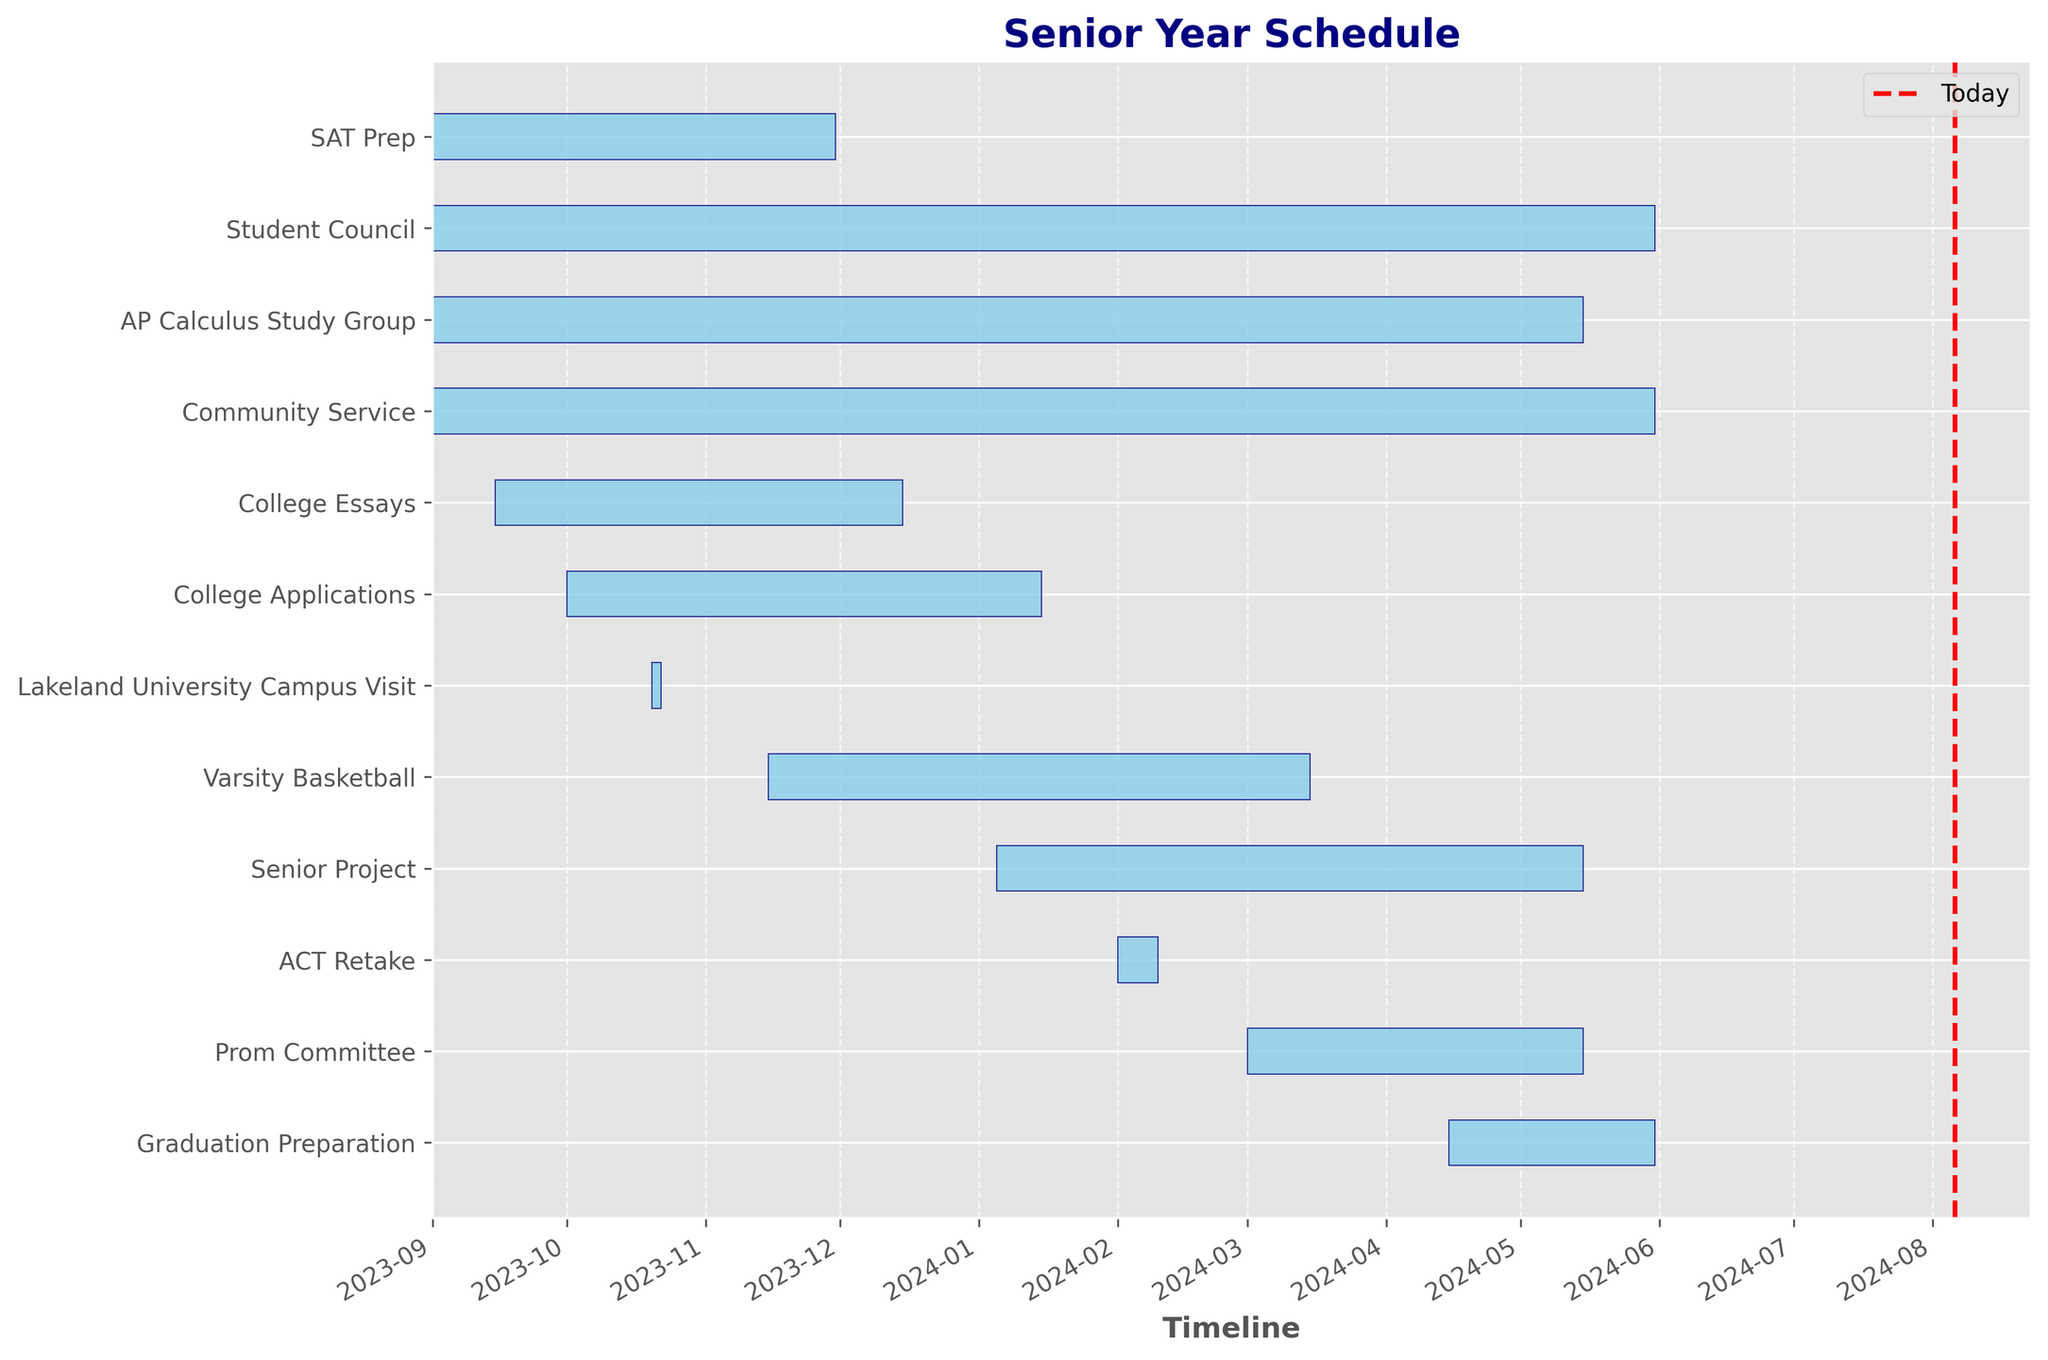What is the title of the chart? The title is located at the top center of the chart and usually provides a summary of what the chart is about. On this chart, the title is bold and colored in navy.
Answer: Senior Year Schedule How many tasks overlap with the SAT Prep period? Look at the bar for the SAT Prep task and observe which bars have start and end dates that fall within its range (2023-09-01 to 2023-11-30).
Answer: 5 (Student Council, AP Calculus Study Group, Community Service, College Applications, College Essays) Which task has the longest duration? Look at the length of each bar. The longest bar visually represents the longest duration. In this case, the Student Council bar is the longest.
Answer: Student Council What is the start date and end date for the Graduation Preparation task? Find the bar labeled "Graduation Preparation" and note the start and end dates at the ends of the bar.
Answer: 2024-04-15 to 2024-05-31 Which activities run through the entire school year? Look for bars that start at the beginning of the school year (around September) and end at the very end (around May or June). These bars include Student Council and Community Service.
Answer: Student Council, Community Service When is the Lakeland University Campus Visit scheduled? Locate the task named "Lakeland University Campus Visit" and observe its position on the timeline.
Answer: 2023-10-20 to 2023-10-22 How many tasks start in October 2023? Look at the start dates associated with each task and count the ones starting in October 2023.
Answer: 2 (College Applications, Lakeland University Campus Visit) Which task ends last in the school year? Find the task whose bar extends the furthest to the right on the timeline, indicating the latest end date.
Answer: Community Service Which tasks overlap with the Prom Committee task? Identify the time range of the Prom Committee task (2024-03-01 to 2024-05-15) and observe which other tasks have date ranges that coincide.
Answer: Varsity Basketball, Senior Project, Graduation Preparation, Student Council, Community Service, AP Calculus Study Group 